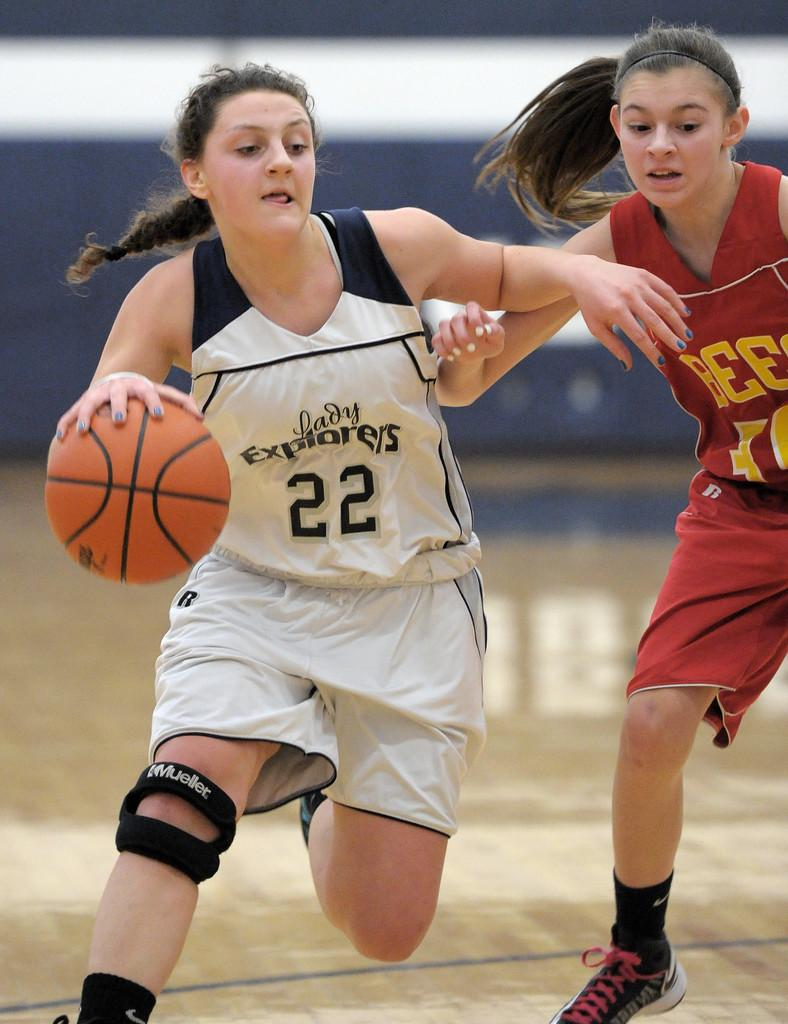Provide a one-sentence caption for the provided image. Lady Explorers number 22 wore a knee brace during a recent game. 